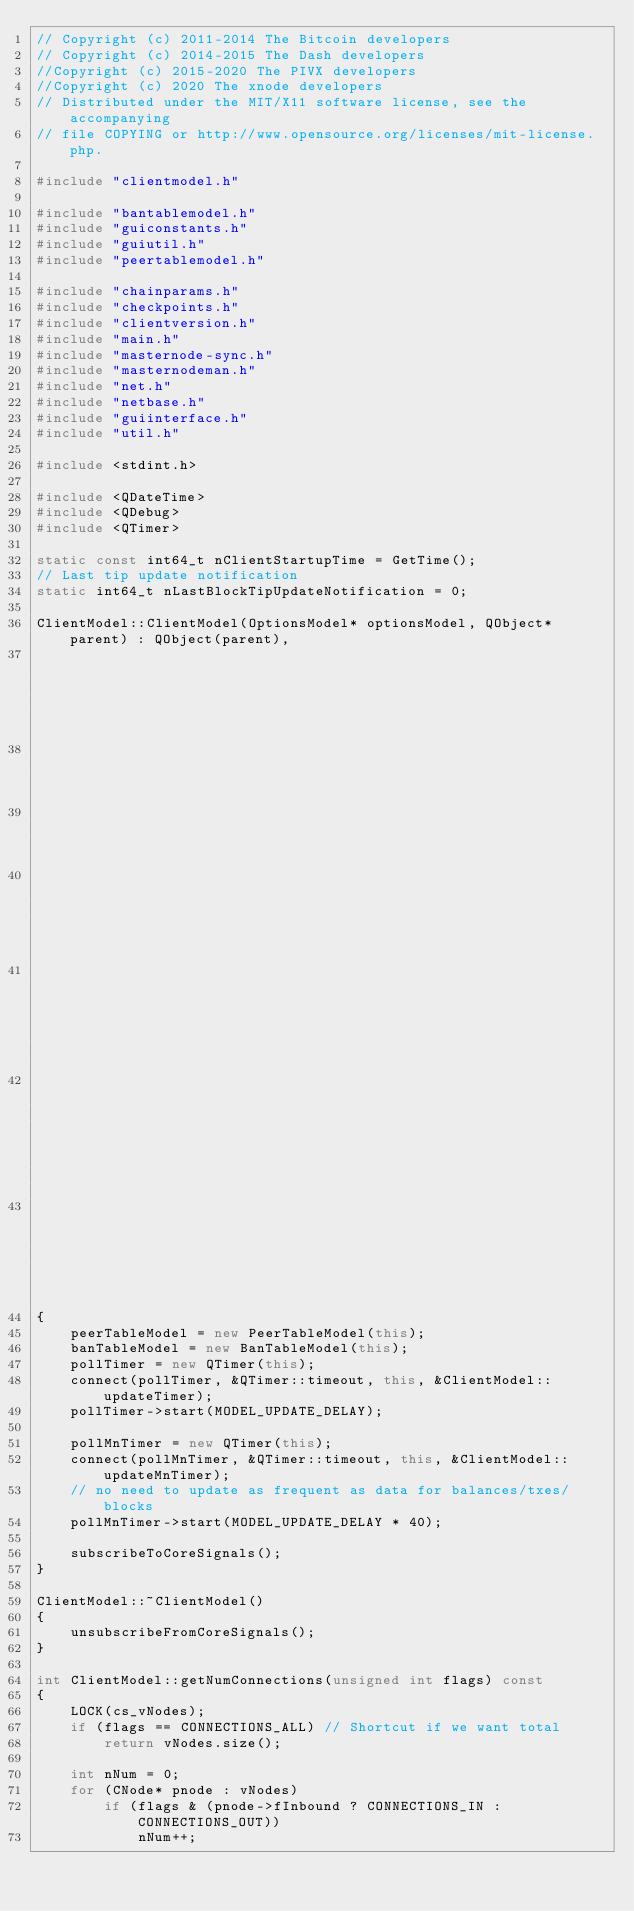Convert code to text. <code><loc_0><loc_0><loc_500><loc_500><_C++_>// Copyright (c) 2011-2014 The Bitcoin developers
// Copyright (c) 2014-2015 The Dash developers
//Copyright (c) 2015-2020 The PIVX developers
//Copyright (c) 2020 The xnode developers
// Distributed under the MIT/X11 software license, see the accompanying
// file COPYING or http://www.opensource.org/licenses/mit-license.php.

#include "clientmodel.h"

#include "bantablemodel.h"
#include "guiconstants.h"
#include "guiutil.h"
#include "peertablemodel.h"

#include "chainparams.h"
#include "checkpoints.h"
#include "clientversion.h"
#include "main.h"
#include "masternode-sync.h"
#include "masternodeman.h"
#include "net.h"
#include "netbase.h"
#include "guiinterface.h"
#include "util.h"

#include <stdint.h>

#include <QDateTime>
#include <QDebug>
#include <QTimer>

static const int64_t nClientStartupTime = GetTime();
// Last tip update notification
static int64_t nLastBlockTipUpdateNotification = 0;

ClientModel::ClientModel(OptionsModel* optionsModel, QObject* parent) : QObject(parent),
                                                                        optionsModel(optionsModel),
                                                                        peerTableModel(0),
                                                                        banTableModel(0),
                                                                        cacheTip(nullptr),
                                                                        cachedMasternodeCountString(""),
                                                                        cachedReindexing(0), cachedImporting(0),
                                                                        numBlocksAtStartup(-1), pollTimer(0)
{
    peerTableModel = new PeerTableModel(this);
    banTableModel = new BanTableModel(this);
    pollTimer = new QTimer(this);
    connect(pollTimer, &QTimer::timeout, this, &ClientModel::updateTimer);
    pollTimer->start(MODEL_UPDATE_DELAY);

    pollMnTimer = new QTimer(this);
    connect(pollMnTimer, &QTimer::timeout, this, &ClientModel::updateMnTimer);
    // no need to update as frequent as data for balances/txes/blocks
    pollMnTimer->start(MODEL_UPDATE_DELAY * 40);

    subscribeToCoreSignals();
}

ClientModel::~ClientModel()
{
    unsubscribeFromCoreSignals();
}

int ClientModel::getNumConnections(unsigned int flags) const
{
    LOCK(cs_vNodes);
    if (flags == CONNECTIONS_ALL) // Shortcut if we want total
        return vNodes.size();

    int nNum = 0;
    for (CNode* pnode : vNodes)
        if (flags & (pnode->fInbound ? CONNECTIONS_IN : CONNECTIONS_OUT))
            nNum++;
</code> 